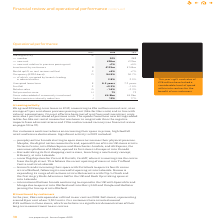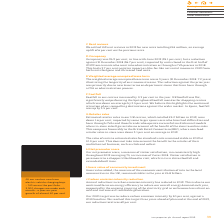From Intu Properties's financial document, What are the components of leasing activity? The document contains multiple relevant values: number, new rent, new rent relative to previous passing rent. From the document: "— new rent relative to previous passing rent +1% +6% Investment by customers B £125m £144m Rental uplift on rent reviews settled C +6% +7% Occup — num..." Also, What is the amount of investment in the stores made by customers in 2019? According to the financial document, £125 million. The relevant text states: "ur 3,300 units. Our customers have invested around £125 million in these stores, which we believe is a significant demonstration of their long-term commitment to ou..." Also, What is the total number of units the Company has? According to the financial document, 3,300 units. The relevant text states: "62 stores), representing around 8 per cent of our 3,300 units. Our customers have invested around £125 million in these stores, which we believe is a significant..." Also, can you calculate: What is the percentage change in the number of leasing activity from 2018 to 2019? To answer this question, I need to perform calculations using the financial data. The calculation is: (205-24)/24, which equals 754.17 (percentage). This is based on the information: "— number 205 248 — number 205 248..." The key data points involved are: 205, 24. Also, can you calculate: What is the percentage change in the investment by customers from 2018 to 2019? To answer this question, I need to perform calculations using the financial data. The calculation is: (125-144)/144, which equals -13.19 (percentage). This is based on the information: "ing rent +1% +6% Investment by customers B £125m £144m Rental uplift on rent reviews settled C +6% +7% Occupancy (EPRA basis) D 94.9% 96.7% s passing rent +1% +6% Investment by customers B £125m £144m..." The key data points involved are: 125, 144. Also, can you calculate: What is the percentage change in the number of opened or refitted unites in the centres from 2018 to 2019? To answer this question, I need to perform calculations using the financial data. The calculation is: (256-262)/262, which equals -2.29 (percentage). This is based on the information: "56 units opened or refitted in our centres (2018: 262 stores), representing around 8 per cent of our 3,300 units. Our customers have invested around £125 B Investment by customers In the year, 256 uni..." The key data points involved are: 256, 262. 